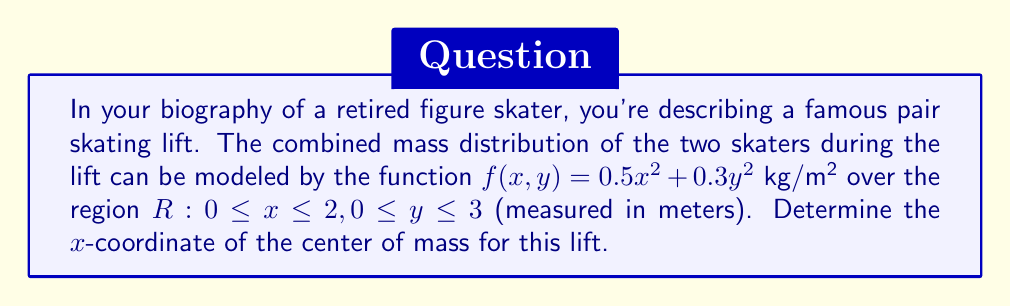Solve this math problem. To find the x-coordinate of the center of mass, we need to follow these steps:

1) The formula for the x-coordinate of the center of mass is:

   $$\bar{x} = \frac{\iint_R xf(x,y) dA}{\iint_R f(x,y) dA}$$

2) First, let's evaluate the numerator:
   $$\iint_R xf(x,y) dA = \int_0^3 \int_0^2 x(0.5x^2 + 0.3y^2) dx dy$$

3) Evaluate the inner integral:
   $$\int_0^3 \left[\frac{0.5x^4}{4} + \frac{0.3y^2x^2}{2}\right]_0^2 dy$$
   $$= \int_0^3 (2 + 0.6y^2) dy$$

4) Evaluate the outer integral:
   $$\left[2y + 0.2y^3\right]_0^3 = 6 + 5.4 = 11.4$$

5) Now, let's evaluate the denominator:
   $$\iint_R f(x,y) dA = \int_0^3 \int_0^2 (0.5x^2 + 0.3y^2) dx dy$$

6) Evaluate the inner integral:
   $$\int_0^3 \left[\frac{0.5x^3}{3} + 0.3y^2x\right]_0^2 dy$$
   $$= \int_0^3 (\frac{4}{3} + 0.6y^2) dy$$

7) Evaluate the outer integral:
   $$\left[\frac{4y}{3} + 0.2y^3\right]_0^3 = 4 + 5.4 = 9.4$$

8) Finally, calculate $\bar{x}$:
   $$\bar{x} = \frac{11.4}{9.4} = \frac{60}{49} \approx 1.224 \text{ m}$$
Answer: $\frac{60}{49}$ m 